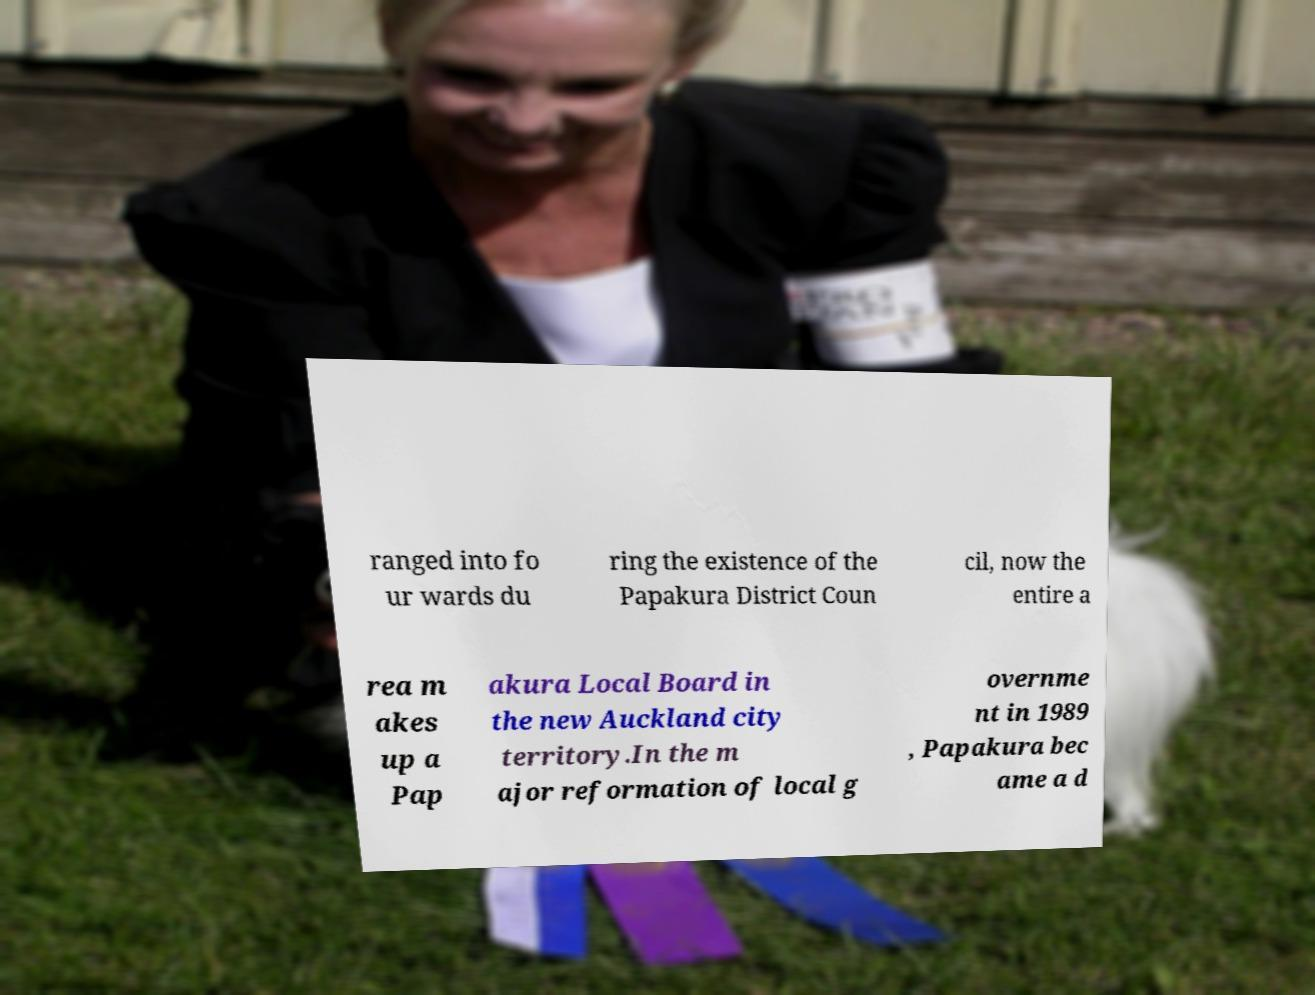What messages or text are displayed in this image? I need them in a readable, typed format. ranged into fo ur wards du ring the existence of the Papakura District Coun cil, now the entire a rea m akes up a Pap akura Local Board in the new Auckland city territory.In the m ajor reformation of local g overnme nt in 1989 , Papakura bec ame a d 